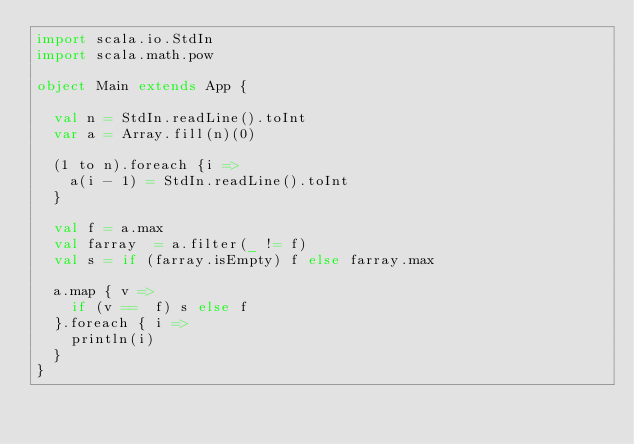Convert code to text. <code><loc_0><loc_0><loc_500><loc_500><_Scala_>import scala.io.StdIn
import scala.math.pow

object Main extends App {

  val n = StdIn.readLine().toInt
  var a = Array.fill(n)(0)

  (1 to n).foreach {i =>
    a(i - 1) = StdIn.readLine().toInt
  }

  val f = a.max
  val farray  = a.filter(_ != f)
  val s = if (farray.isEmpty) f else farray.max

  a.map { v =>
    if (v ==  f) s else f
  }.foreach { i =>
    println(i)
  }
}
  

</code> 